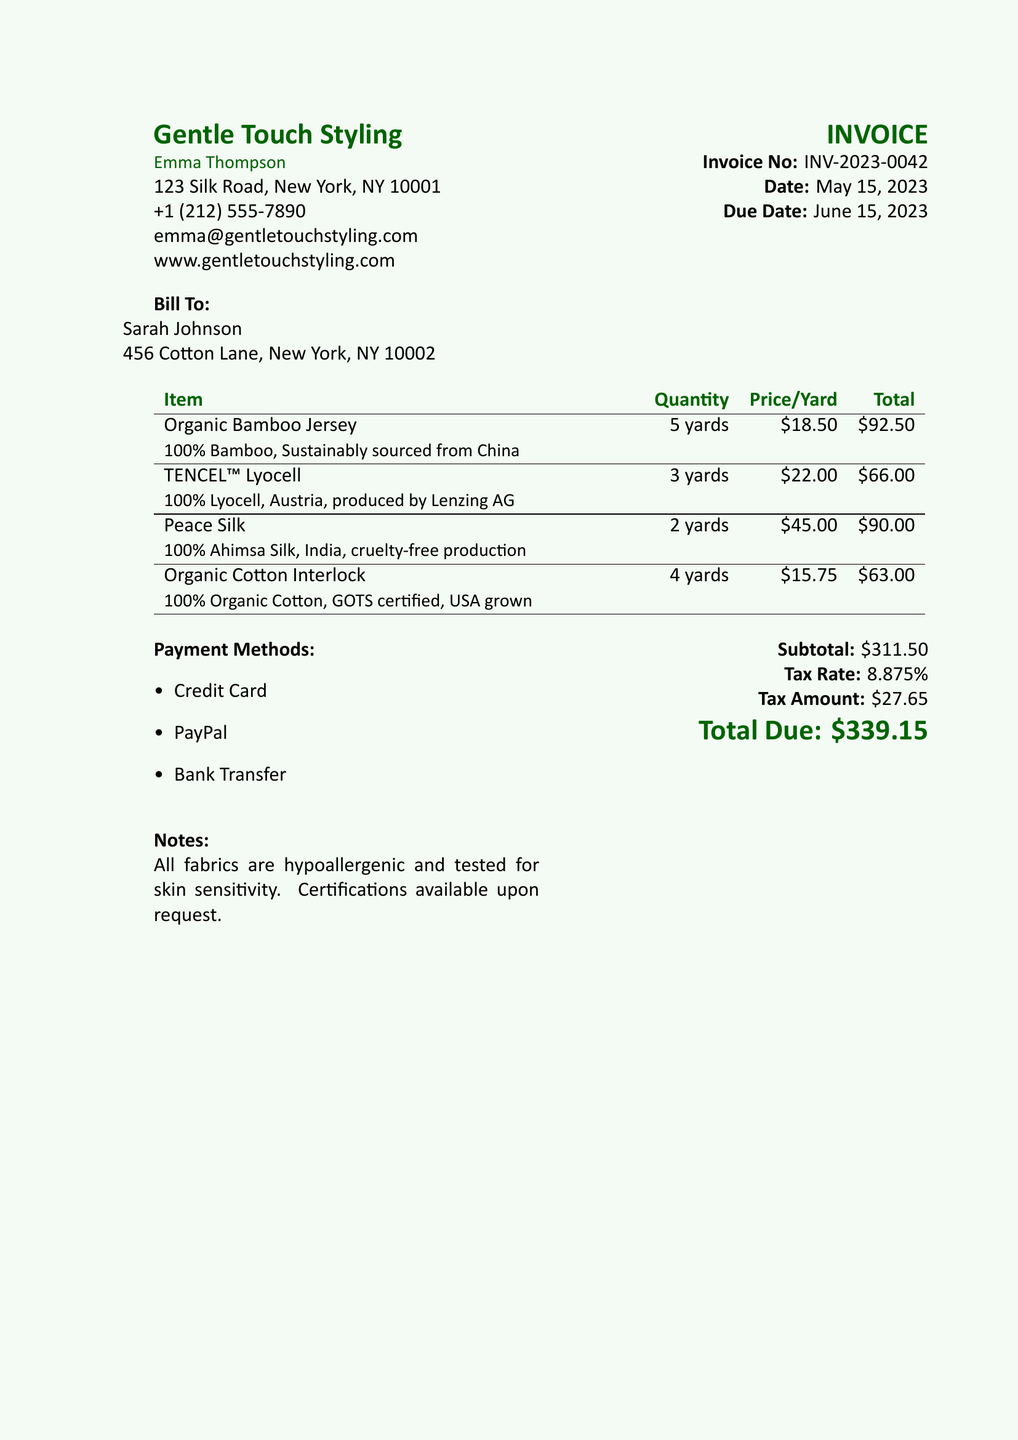What is the invoice number? The invoice number is a unique identifier for the transaction, found in the document as "Invoice No: INV-2023-0042."
Answer: INV-2023-0042 What is the total due amount? The total due amount is the final balance listed at the bottom of the invoice, which is "$339.15."
Answer: $339.15 Who is the bill sent to? The recipient of the bill is specified in the "Bill To" section as "Sarah Johnson."
Answer: Sarah Johnson What are the payment methods available? The payment methods are listed in the document, specifying options available to the client.
Answer: Credit Card, PayPal, Bank Transfer Which fabric has the highest price per yard? This involves comparing the listed prices per yard to find the highest one; the price is noted next to each fabric type.
Answer: Peace Silk How many yards of TENCEL™ Lyocell were purchased? This requires looking at the table to find the quantity of TENCEL™ Lyocell listed.
Answer: 3 yards What is the tax rate applied to the invoice? The document states the applicable tax rate which is needed to calculate the tax amount.
Answer: 8.875% Where is the organic cotton sourced from? The place of origin for the organic cotton is mentioned under its description in the table.
Answer: USA grown Is all the fabric hypoallergenic? The document includes a note about the attributes of the fabrics provided, confirming their hypoallergenic nature.
Answer: Yes 